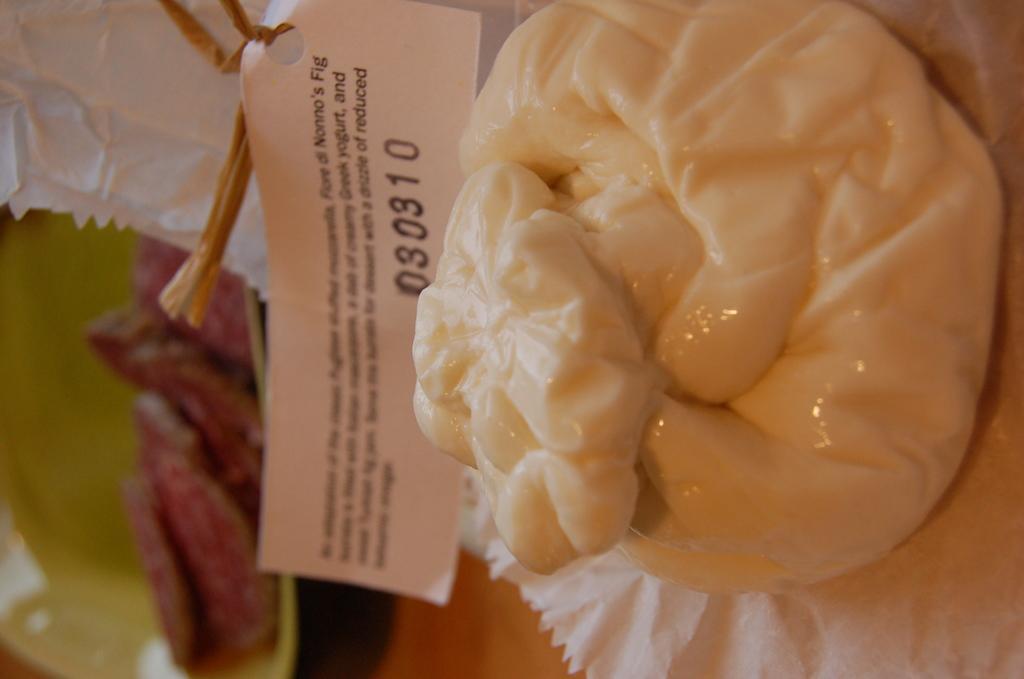Describe this image in one or two sentences. In this image I can see food which is in cream color on the white color paper. I can also see a plate in green color. 